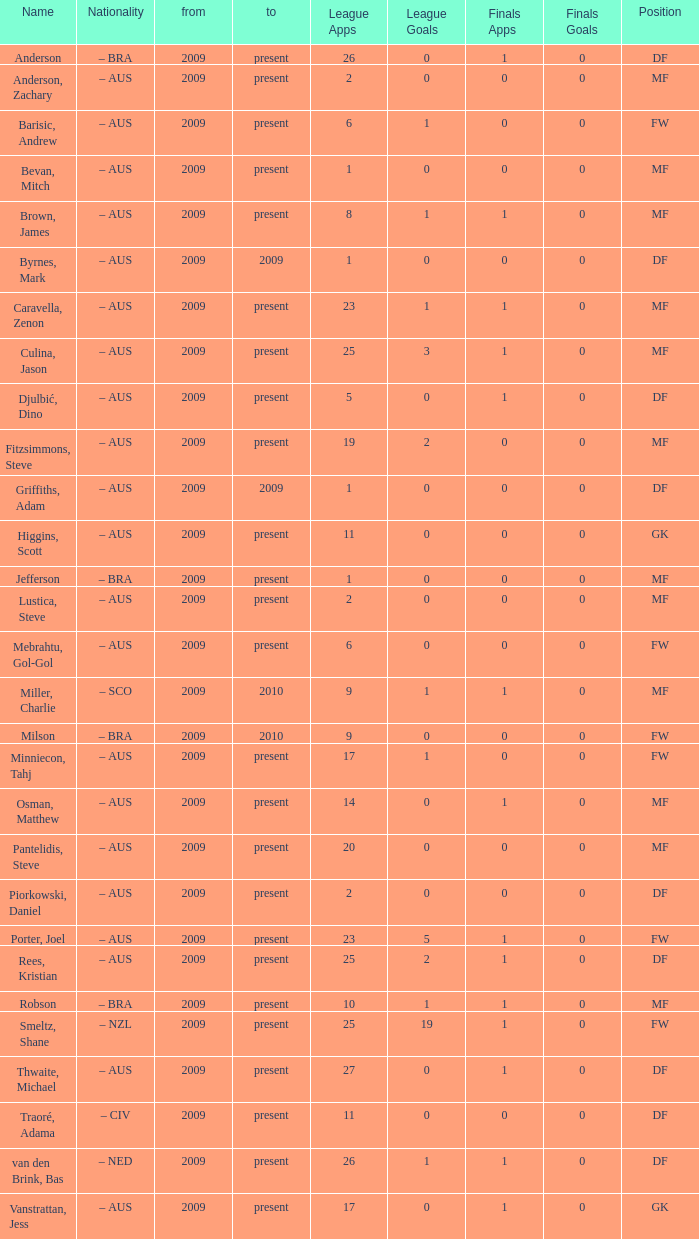List the most championship games participation 1.0. 